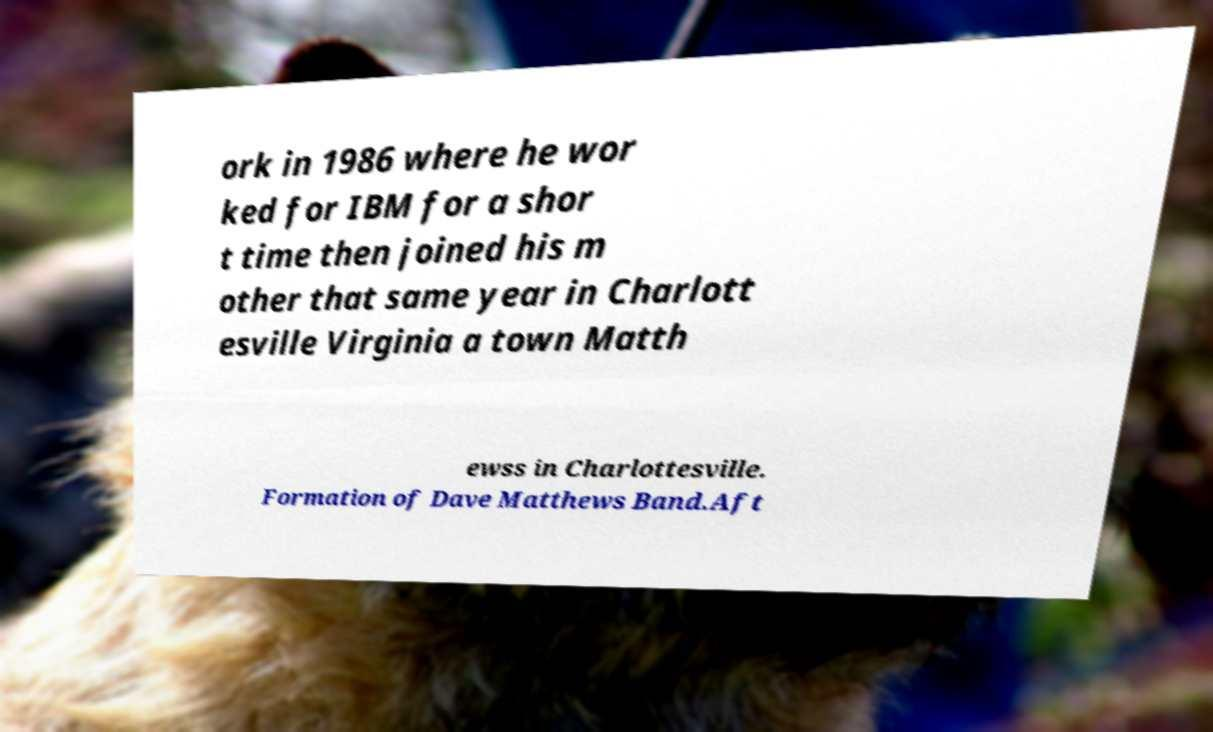What messages or text are displayed in this image? I need them in a readable, typed format. ork in 1986 where he wor ked for IBM for a shor t time then joined his m other that same year in Charlott esville Virginia a town Matth ewss in Charlottesville. Formation of Dave Matthews Band.Aft 